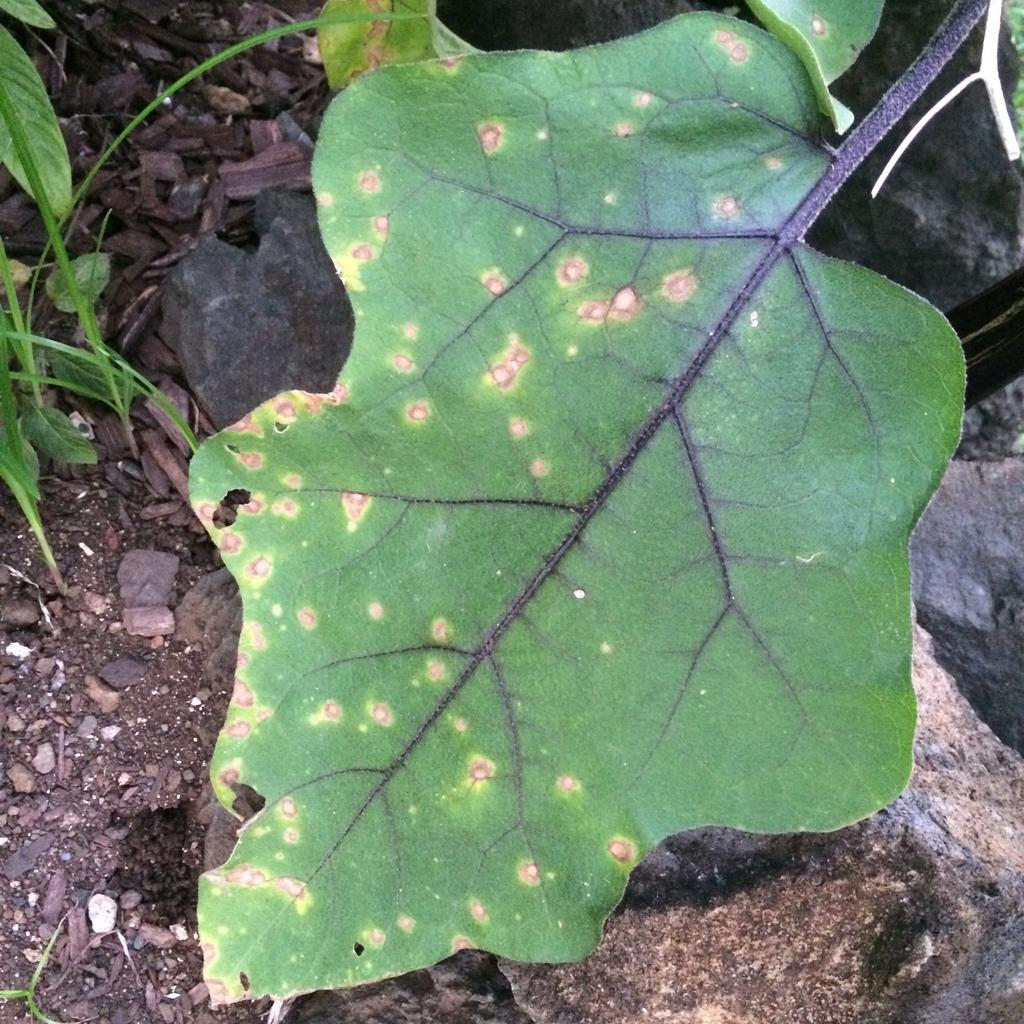What type of living organisms can be seen in the image? Plants can be seen in the image. What is located at the bottom of the image? There are rocks at the bottom of the image. What is the texture of the ground in the image? There is mud in the image. What color are the dots on the leaves of the plants? The dots on the leaves of the plants are pink. Can you describe the part of the rat's body that is visible in the image? There is no rat present in the image, so it is not possible to describe any part of its body. 